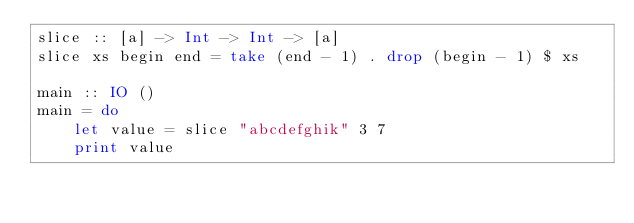Convert code to text. <code><loc_0><loc_0><loc_500><loc_500><_Haskell_>slice :: [a] -> Int -> Int -> [a]
slice xs begin end = take (end - 1) . drop (begin - 1) $ xs

main :: IO ()
main = do
    let value = slice "abcdefghik" 3 7
    print value
</code> 